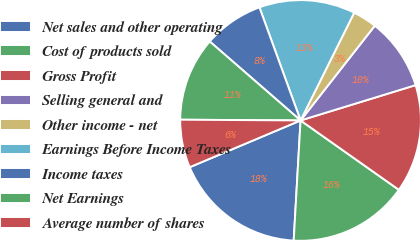<chart> <loc_0><loc_0><loc_500><loc_500><pie_chart><fcel>Net sales and other operating<fcel>Cost of products sold<fcel>Gross Profit<fcel>Selling general and<fcel>Other income - net<fcel>Earnings Before Income Taxes<fcel>Income taxes<fcel>Net Earnings<fcel>Average number of shares<nl><fcel>17.74%<fcel>16.13%<fcel>14.52%<fcel>9.68%<fcel>3.23%<fcel>12.9%<fcel>8.06%<fcel>11.29%<fcel>6.45%<nl></chart> 